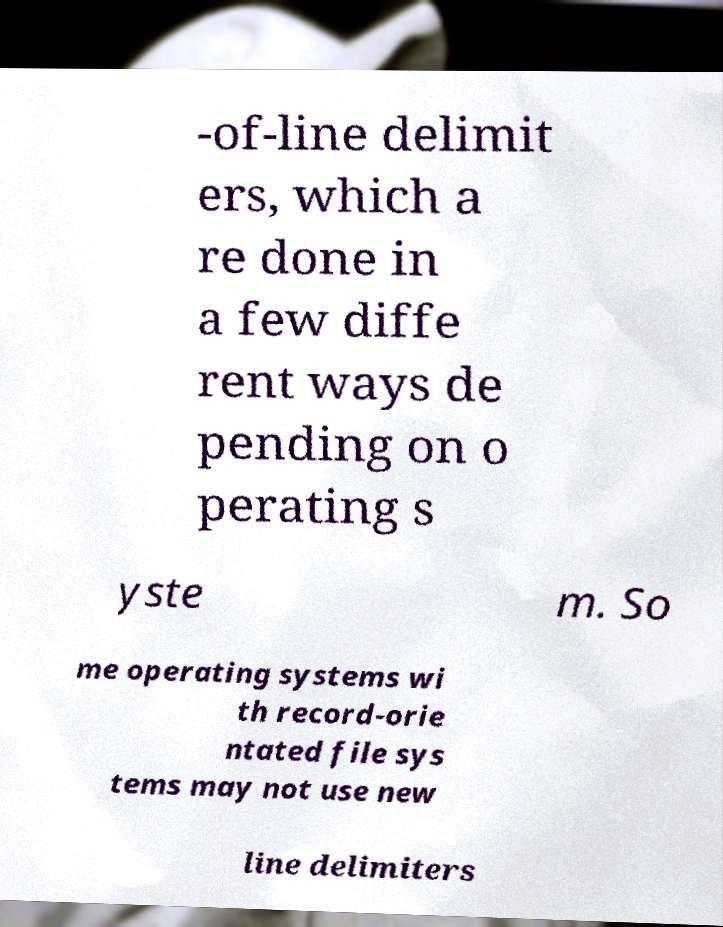Please read and relay the text visible in this image. What does it say? -of-line delimit ers, which a re done in a few diffe rent ways de pending on o perating s yste m. So me operating systems wi th record-orie ntated file sys tems may not use new line delimiters 